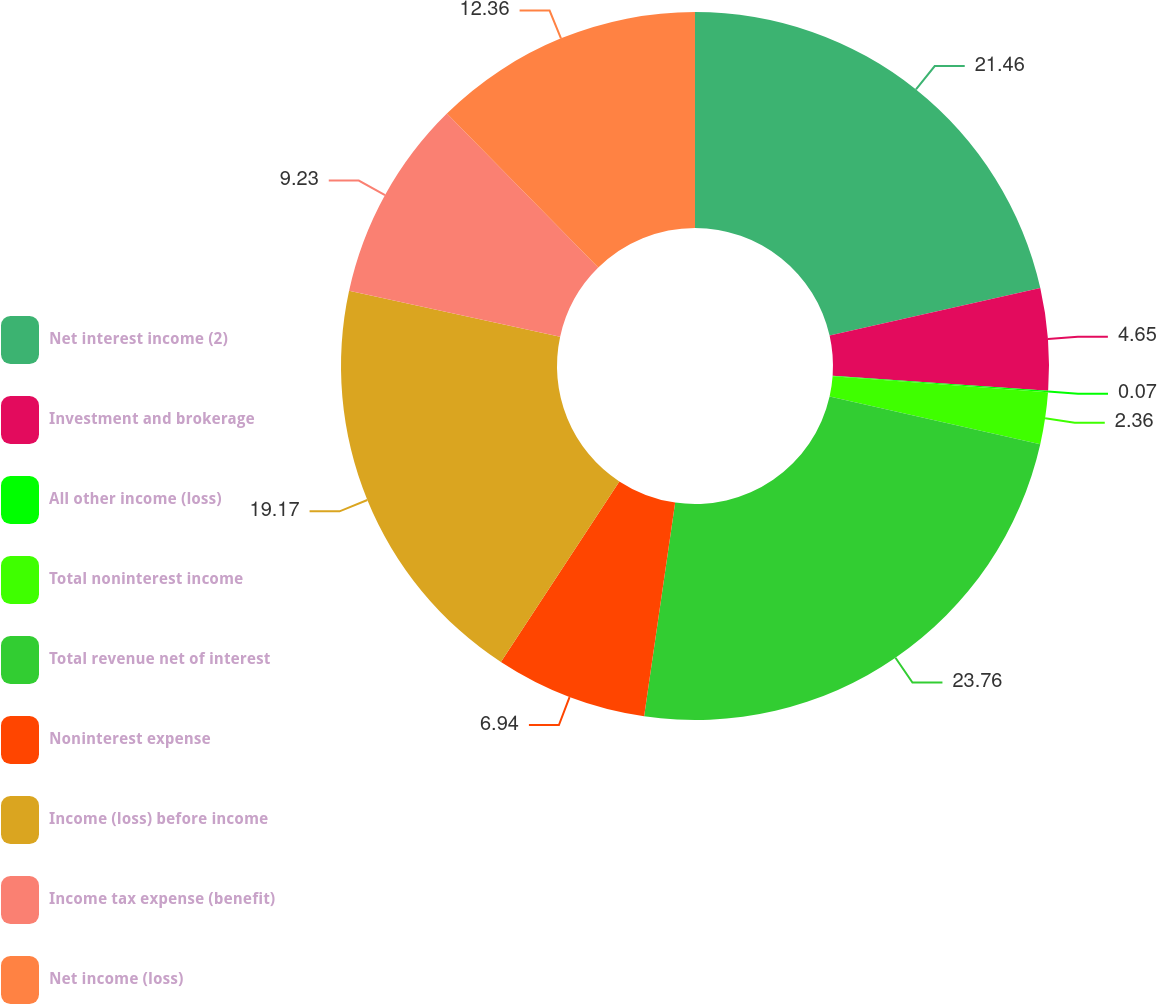<chart> <loc_0><loc_0><loc_500><loc_500><pie_chart><fcel>Net interest income (2)<fcel>Investment and brokerage<fcel>All other income (loss)<fcel>Total noninterest income<fcel>Total revenue net of interest<fcel>Noninterest expense<fcel>Income (loss) before income<fcel>Income tax expense (benefit)<fcel>Net income (loss)<nl><fcel>21.46%<fcel>4.65%<fcel>0.07%<fcel>2.36%<fcel>23.75%<fcel>6.94%<fcel>19.17%<fcel>9.23%<fcel>12.36%<nl></chart> 